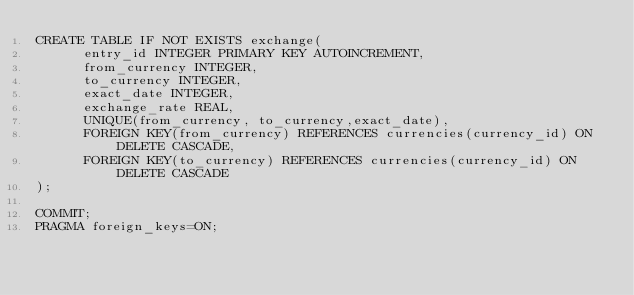Convert code to text. <code><loc_0><loc_0><loc_500><loc_500><_SQL_>CREATE TABLE IF NOT EXISTS exchange(
		  entry_id INTEGER PRIMARY KEY AUTOINCREMENT,
		  from_currency INTEGER,
		  to_currency INTEGER,
		  exact_date INTEGER,
		  exchange_rate REAL,
		  UNIQUE(from_currency, to_currency,exact_date),
		  FOREIGN KEY(from_currency) REFERENCES currencies(currency_id) ON DELETE CASCADE,
		  FOREIGN KEY(to_currency) REFERENCES currencies(currency_id) ON DELETE CASCADE
);
  
COMMIT;
PRAGMA foreign_keys=ON;

</code> 